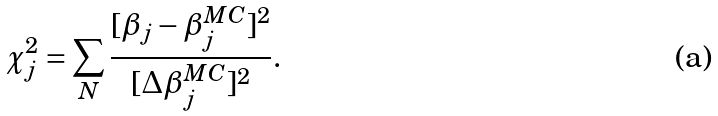Convert formula to latex. <formula><loc_0><loc_0><loc_500><loc_500>\chi _ { j } ^ { 2 } = \sum _ { N } \frac { [ \beta _ { j } - \beta _ { j } ^ { M C } ] ^ { 2 } } { [ \Delta \beta _ { j } ^ { M C } ] ^ { 2 } } .</formula> 